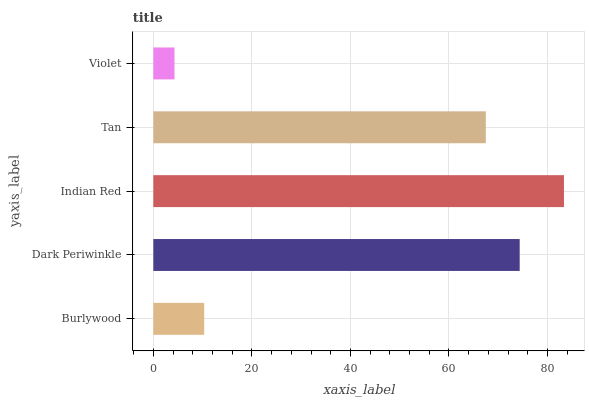Is Violet the minimum?
Answer yes or no. Yes. Is Indian Red the maximum?
Answer yes or no. Yes. Is Dark Periwinkle the minimum?
Answer yes or no. No. Is Dark Periwinkle the maximum?
Answer yes or no. No. Is Dark Periwinkle greater than Burlywood?
Answer yes or no. Yes. Is Burlywood less than Dark Periwinkle?
Answer yes or no. Yes. Is Burlywood greater than Dark Periwinkle?
Answer yes or no. No. Is Dark Periwinkle less than Burlywood?
Answer yes or no. No. Is Tan the high median?
Answer yes or no. Yes. Is Tan the low median?
Answer yes or no. Yes. Is Burlywood the high median?
Answer yes or no. No. Is Indian Red the low median?
Answer yes or no. No. 